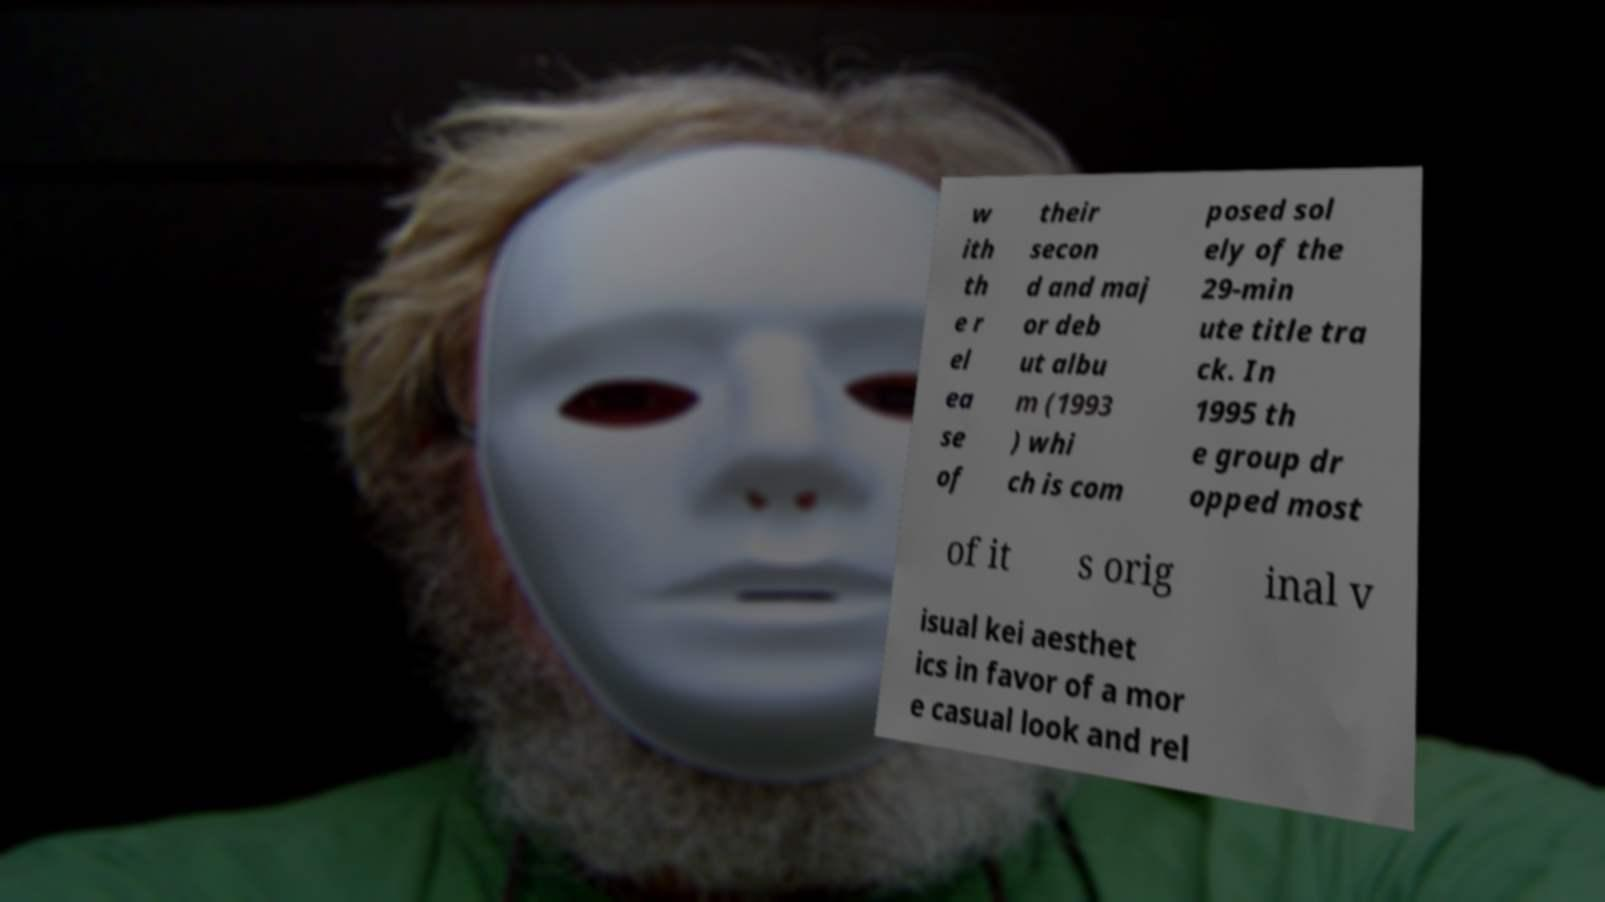For documentation purposes, I need the text within this image transcribed. Could you provide that? w ith th e r el ea se of their secon d and maj or deb ut albu m (1993 ) whi ch is com posed sol ely of the 29-min ute title tra ck. In 1995 th e group dr opped most of it s orig inal v isual kei aesthet ics in favor of a mor e casual look and rel 